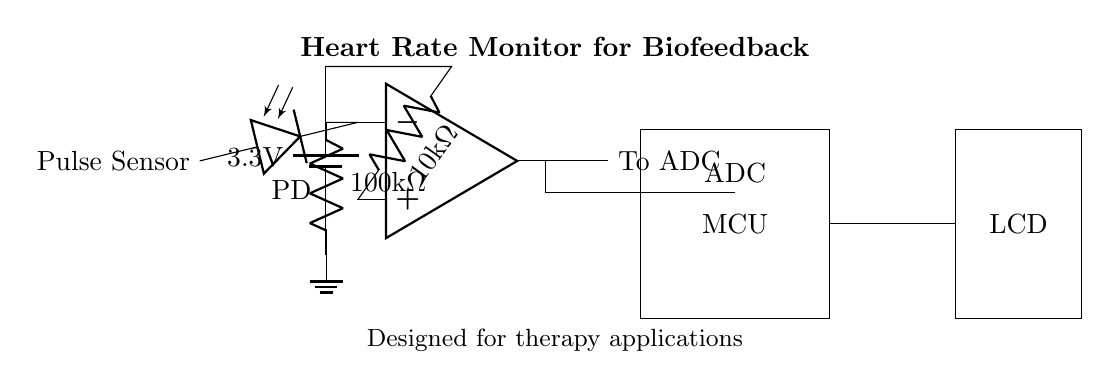What is the voltage supplied to this circuit? The circuit diagram shows a 3.3V battery providing power, indicated by the label on the battery symbol, which specifies the voltage.
Answer: 3.3V What is the resistance value of the first resistor? The first resistor in the circuit is labeled as 10k ohms, which can be read directly from the resistor symbol connected to the op-amp's non-inverting input.
Answer: 10k ohms How many components are connected to the op-amp's output? The op-amp's output connects to one line directed to the ADC, which can be seen extending from the op-amp and labeled as "To ADC."
Answer: 1 What type of sensor is used in this circuit? The diagram labels the leftmost component as "Pulse Sensor," identifying the type of sensor used for detecting heart rate.
Answer: Pulse Sensor What is the function of the microcontroller in this circuit? The microcontroller, labeled as "MCU," receives the analog signal from the ADC, processes it, and is responsible for handling the data presented to the output display, which is indicated by its connection points.
Answer: Data processing What happens to the signal before it reaches the microcontroller? The signal from the op-amp output goes to the analog-to-digital converter (ADC) before reaching the microcontroller, as shown by the path outlined in the diagram where the op-amp output connects to the ADC input.
Answer: Goes to ADC What is located on the output side of the circuit? The LCD display is present on the output side of the circuit, as indicated by the rectangle labeled "LCD," showcasing how processed data will be presented.
Answer: LCD 